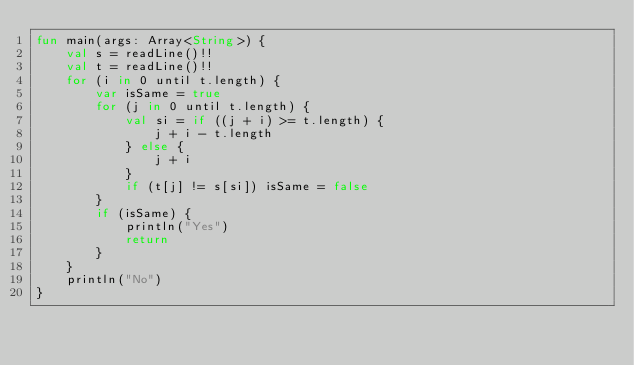Convert code to text. <code><loc_0><loc_0><loc_500><loc_500><_Kotlin_>fun main(args: Array<String>) {
    val s = readLine()!!
    val t = readLine()!!
    for (i in 0 until t.length) {
        var isSame = true
        for (j in 0 until t.length) {
            val si = if ((j + i) >= t.length) {
                j + i - t.length
            } else {
                j + i
            }
            if (t[j] != s[si]) isSame = false
        }
        if (isSame) {
            println("Yes")
            return
        }
    }
    println("No")
}</code> 